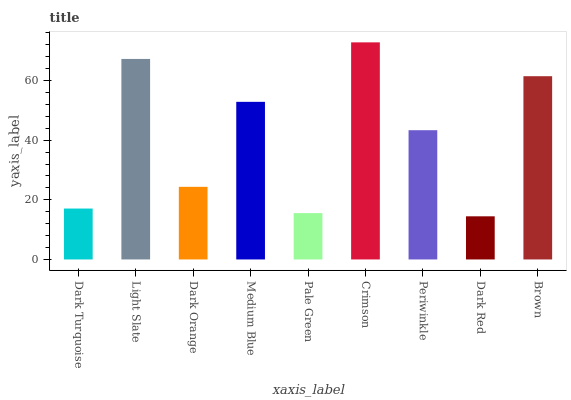Is Dark Red the minimum?
Answer yes or no. Yes. Is Crimson the maximum?
Answer yes or no. Yes. Is Light Slate the minimum?
Answer yes or no. No. Is Light Slate the maximum?
Answer yes or no. No. Is Light Slate greater than Dark Turquoise?
Answer yes or no. Yes. Is Dark Turquoise less than Light Slate?
Answer yes or no. Yes. Is Dark Turquoise greater than Light Slate?
Answer yes or no. No. Is Light Slate less than Dark Turquoise?
Answer yes or no. No. Is Periwinkle the high median?
Answer yes or no. Yes. Is Periwinkle the low median?
Answer yes or no. Yes. Is Light Slate the high median?
Answer yes or no. No. Is Brown the low median?
Answer yes or no. No. 